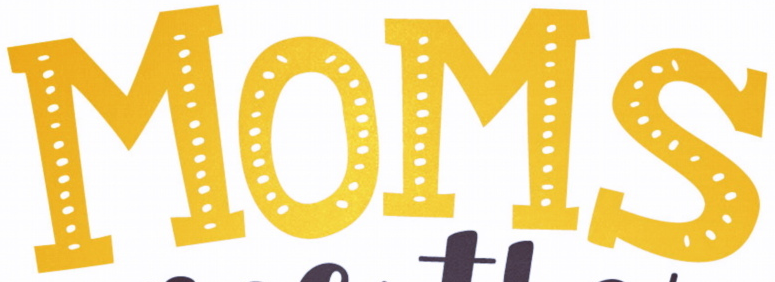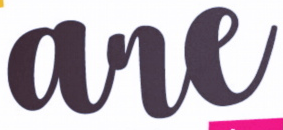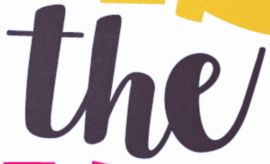What words can you see in these images in sequence, separated by a semicolon? MOMS; are; the 